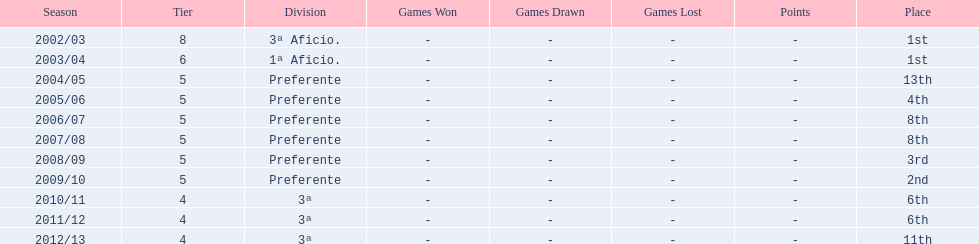Which seasons were played in tier four? 2010/11, 2011/12, 2012/13. Of these seasons, which resulted in 6th place? 2010/11, 2011/12. Which of the remaining happened last? 2011/12. I'm looking to parse the entire table for insights. Could you assist me with that? {'header': ['Season', 'Tier', 'Division', 'Games Won', 'Games Drawn', 'Games Lost', 'Points', 'Place'], 'rows': [['2002/03', '8', '3ª Aficio.', '-', '-', '-', '-', '1st'], ['2003/04', '6', '1ª Aficio.', '-', '-', '-', '-', '1st'], ['2004/05', '5', 'Preferente', '-', '-', '-', '-', '13th'], ['2005/06', '5', 'Preferente', '-', '-', '-', '-', '4th'], ['2006/07', '5', 'Preferente', '-', '-', '-', '-', '8th'], ['2007/08', '5', 'Preferente', '-', '-', '-', '-', '8th'], ['2008/09', '5', 'Preferente', '-', '-', '-', '-', '3rd'], ['2009/10', '5', 'Preferente', '-', '-', '-', '-', '2nd'], ['2010/11', '4', '3ª', '-', '-', '-', '-', '6th'], ['2011/12', '4', '3ª', '-', '-', '-', '-', '6th'], ['2012/13', '4', '3ª', '-', '-', '-', '-', '11th']]} 